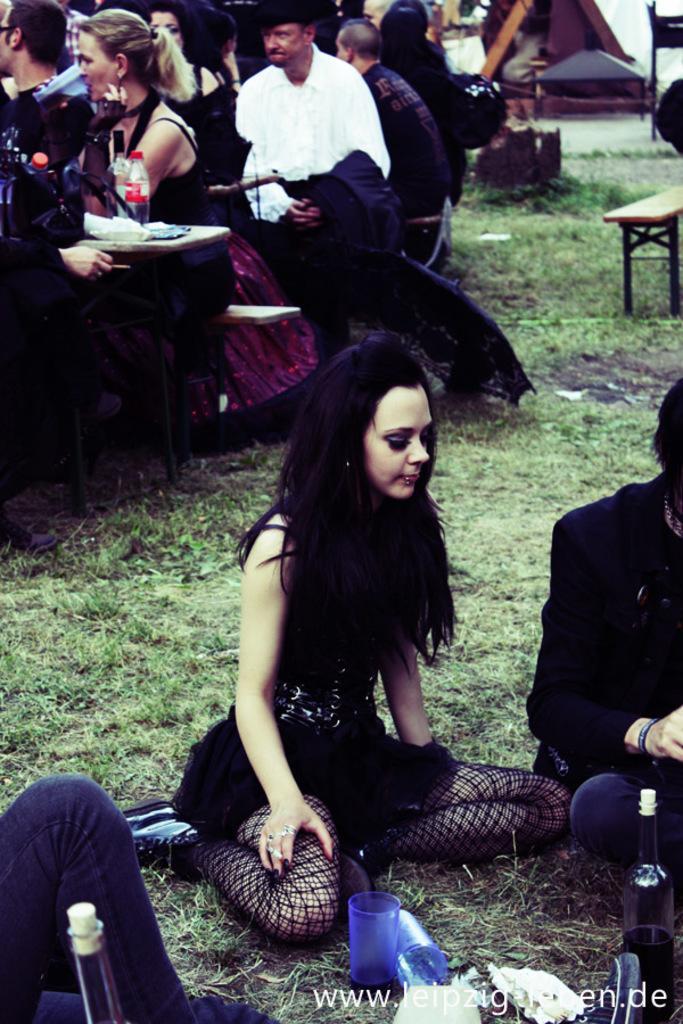Can you describe this image briefly? In this image we can see some people and among them few people sitting on the ground and there are some objects like glasses, bottles and some other things on the ground. We can see few people sitting on benches and there is a table with some objects. 